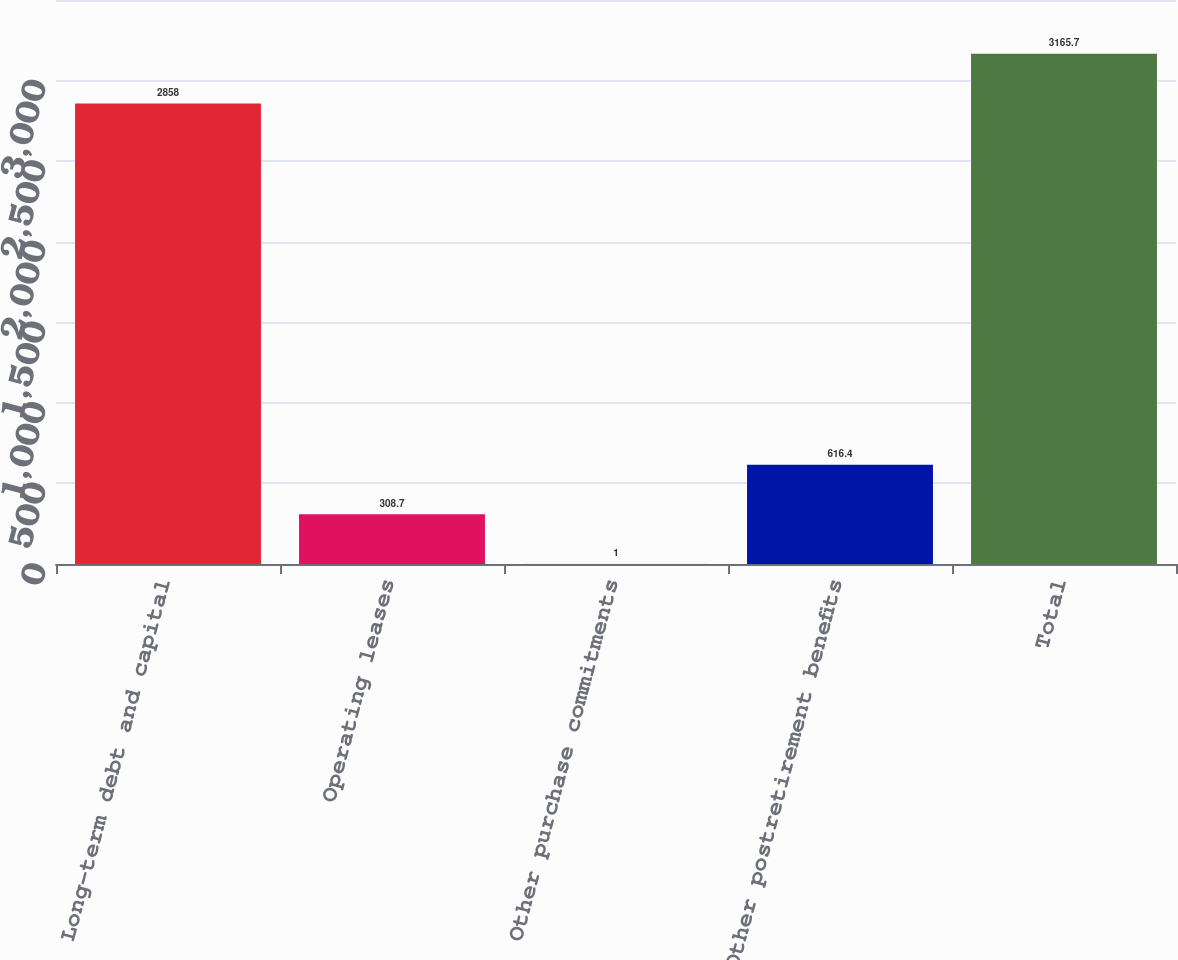Convert chart. <chart><loc_0><loc_0><loc_500><loc_500><bar_chart><fcel>Long-term debt and capital<fcel>Operating leases<fcel>Other purchase commitments<fcel>Other postretirement benefits<fcel>Total<nl><fcel>2858<fcel>308.7<fcel>1<fcel>616.4<fcel>3165.7<nl></chart> 